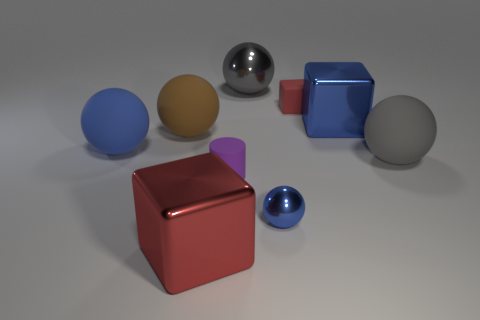Subtract all red cubes. How many were subtracted if there are1red cubes left? 1 Subtract all large shiny balls. How many balls are left? 4 Subtract all blue blocks. How many blocks are left? 2 Subtract all cylinders. How many objects are left? 8 Subtract 3 balls. How many balls are left? 2 Subtract all blue spheres. Subtract all red cylinders. How many spheres are left? 3 Subtract all purple cubes. How many red balls are left? 0 Subtract all red objects. Subtract all tiny matte blocks. How many objects are left? 6 Add 2 brown spheres. How many brown spheres are left? 3 Add 7 big blue rubber cylinders. How many big blue rubber cylinders exist? 7 